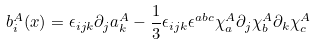<formula> <loc_0><loc_0><loc_500><loc_500>b _ { i } ^ { A } ( x ) = \epsilon _ { i j k } \partial _ { j } a _ { k } ^ { A } - \frac { 1 } { 3 } \epsilon _ { i j k } \epsilon ^ { a b c } \chi _ { a } ^ { A } \partial _ { j } \chi _ { b } ^ { A } \partial _ { k } \chi _ { c } ^ { A }</formula> 